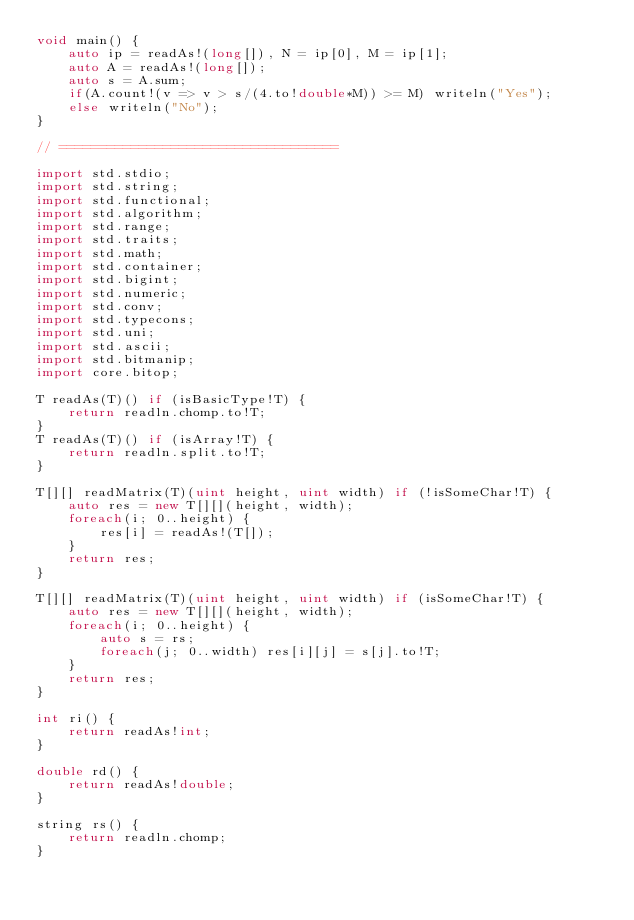Convert code to text. <code><loc_0><loc_0><loc_500><loc_500><_D_>void main() {
	auto ip = readAs!(long[]), N = ip[0], M = ip[1];
	auto A = readAs!(long[]);
	auto s = A.sum;
	if(A.count!(v => v > s/(4.to!double*M)) >= M) writeln("Yes");
	else writeln("No");
}

// ===================================

import std.stdio;
import std.string;
import std.functional;
import std.algorithm;
import std.range;
import std.traits;
import std.math;
import std.container;
import std.bigint;
import std.numeric;
import std.conv;
import std.typecons;
import std.uni;
import std.ascii;
import std.bitmanip;
import core.bitop;

T readAs(T)() if (isBasicType!T) {
	return readln.chomp.to!T;
}
T readAs(T)() if (isArray!T) {
	return readln.split.to!T;
}

T[][] readMatrix(T)(uint height, uint width) if (!isSomeChar!T) {
	auto res = new T[][](height, width);
	foreach(i; 0..height) {
		res[i] = readAs!(T[]);
	}
	return res;
}

T[][] readMatrix(T)(uint height, uint width) if (isSomeChar!T) {
	auto res = new T[][](height, width);
	foreach(i; 0..height) {
		auto s = rs;
		foreach(j; 0..width) res[i][j] = s[j].to!T;
	}
	return res;
}

int ri() {
	return readAs!int;
}

double rd() {
	return readAs!double;
}

string rs() {
	return readln.chomp;
}</code> 